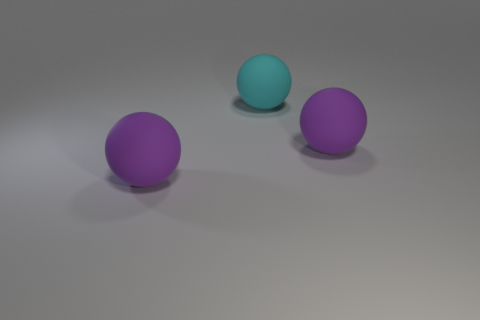Add 2 purple spheres. How many objects exist? 5 Add 2 purple rubber blocks. How many purple rubber blocks exist? 2 Subtract 0 cyan cubes. How many objects are left? 3 Subtract all big purple rubber objects. Subtract all big cyan matte spheres. How many objects are left? 0 Add 3 big purple balls. How many big purple balls are left? 5 